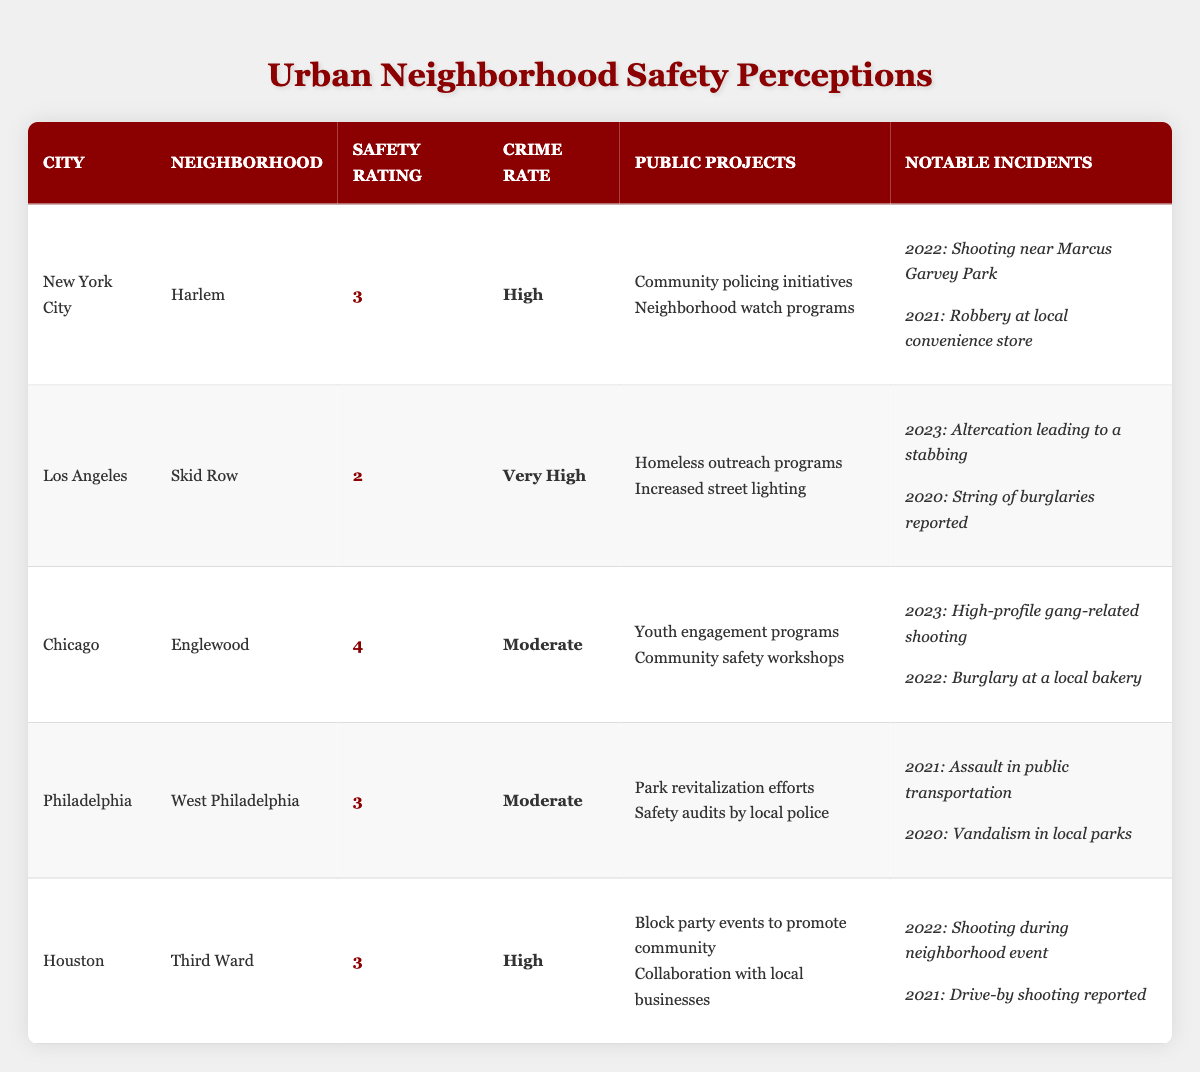What is the public safety rating for Skid Row in Los Angeles? The table shows a public safety rating of 2 for Skid Row.
Answer: 2 Which neighborhood has the highest public safety rating? Englewood has the highest public safety rating, which is 4.
Answer: Englewood What is the crime rate in Harlem? The crime rate in Harlem is categorized as High.
Answer: High Did any notable incidents occur in Philadelphia in 2021? Yes, there was an assault in public transportation in 2021.
Answer: Yes Which city has the same public safety rating as West Philadelphia? Both Harlem and Third Ward have a public safety rating of 3, the same as West Philadelphia.
Answer: Harlem and Third Ward What is the average public safety rating for the neighborhoods listed? To find the average, sum the ratings: (3 + 2 + 4 + 3 + 3) = 15; then divide by 5, which gives 15/5 = 3.
Answer: 3 Is the crime rate for Third Ward higher than that of Englewood? No, Third Ward has a High crime rate while Englewood has a Moderate crime rate, which is lower.
Answer: No What notable incident occurred in Chicago in 2023? The notable incident in Chicago in 2023 was a high-profile gang-related shooting.
Answer: High-profile gang-related shooting Which public project is commonly mentioned for both Harlem and Third Ward? "Community policing initiatives" is mentioned as a public project for Harlem, while Third Ward has "Block party events," so they do not share a common project.
Answer: None How many notable incidents were reported for Skid Row and what year was the most recent? Skid Row had two notable incidents: one in 2023 (stabbing) and another in 2020 (burglaries). The most recent is from 2023.
Answer: 2 incidents, most recent in 2023 